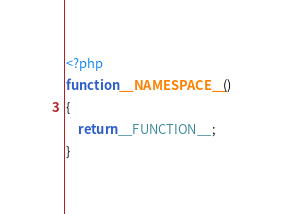<code> <loc_0><loc_0><loc_500><loc_500><_PHP_><?php
function __NAMESPACE__()
{
    return __FUNCTION__;
}
</code> 